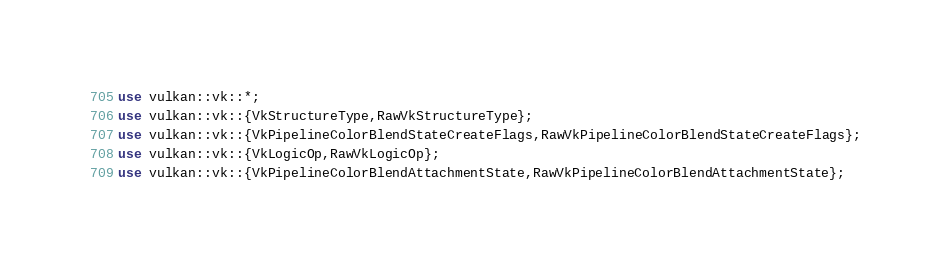Convert code to text. <code><loc_0><loc_0><loc_500><loc_500><_Rust_>use vulkan::vk::*;
use vulkan::vk::{VkStructureType,RawVkStructureType};
use vulkan::vk::{VkPipelineColorBlendStateCreateFlags,RawVkPipelineColorBlendStateCreateFlags};
use vulkan::vk::{VkLogicOp,RawVkLogicOp};
use vulkan::vk::{VkPipelineColorBlendAttachmentState,RawVkPipelineColorBlendAttachmentState};
</code> 